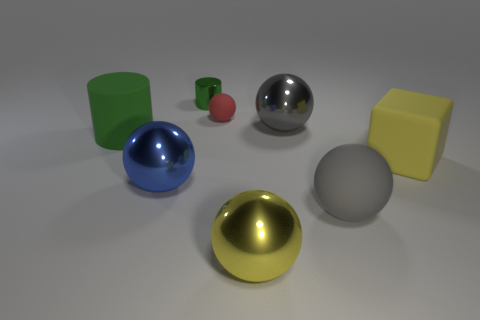Are there any objects that stand out due to their size? Yes, the green cylinder and the yellow cube stand out because they are larger in size relative to the other objects in the image. How do the sizes of these larger objects compare to each other? The green cylinder and the yellow cube are quite similar in size. However, the cylinder appears to be slightly taller, while the cube has a broader base, giving it a more substantial volume. 